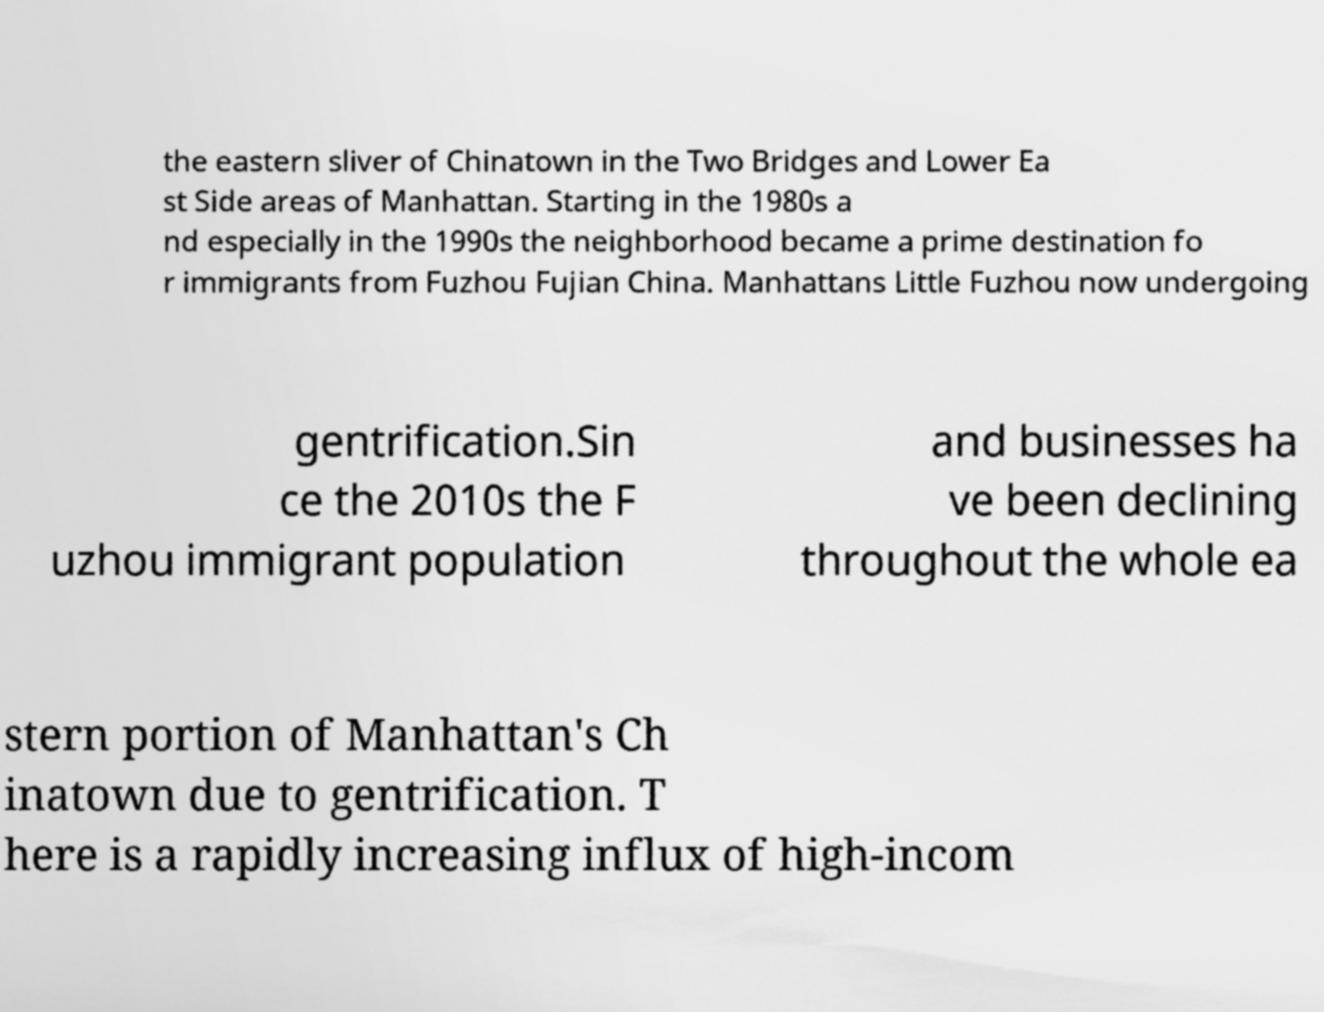Can you read and provide the text displayed in the image?This photo seems to have some interesting text. Can you extract and type it out for me? the eastern sliver of Chinatown in the Two Bridges and Lower Ea st Side areas of Manhattan. Starting in the 1980s a nd especially in the 1990s the neighborhood became a prime destination fo r immigrants from Fuzhou Fujian China. Manhattans Little Fuzhou now undergoing gentrification.Sin ce the 2010s the F uzhou immigrant population and businesses ha ve been declining throughout the whole ea stern portion of Manhattan's Ch inatown due to gentrification. T here is a rapidly increasing influx of high-incom 